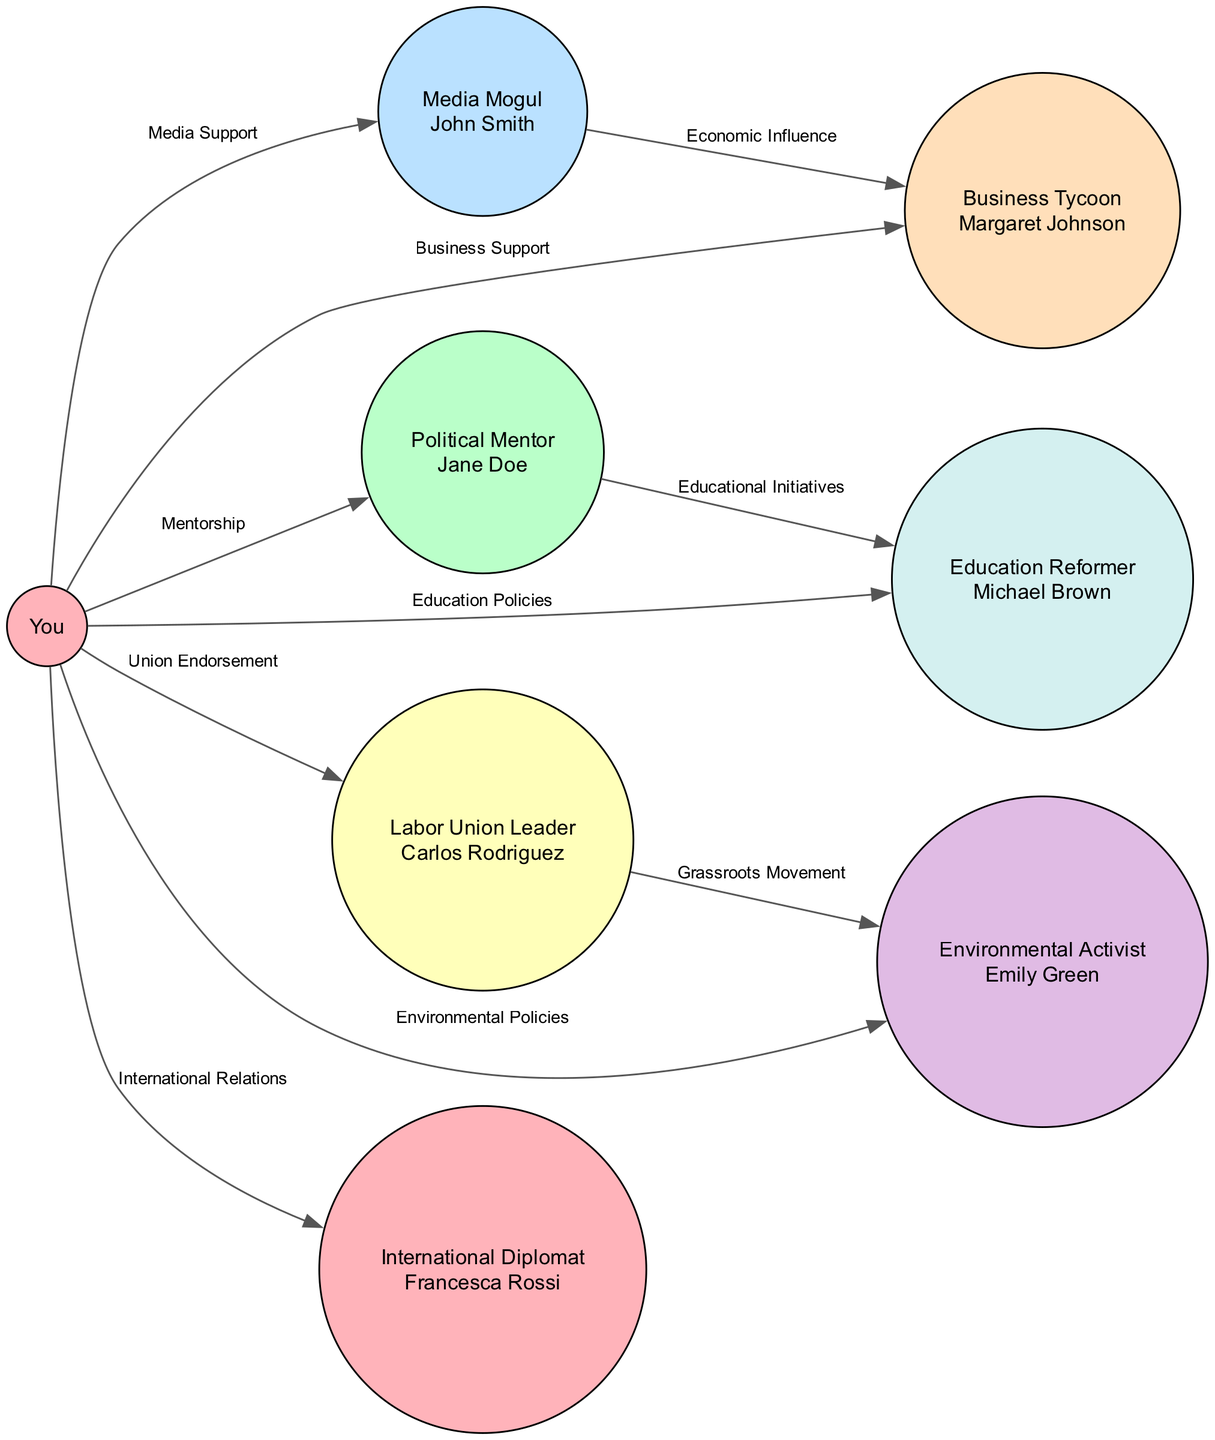What is the total number of nodes in the diagram? The nodes displayed in the diagram include you, political mentor, media mogul, labor union leader, business tycoon, environmental activist, education reformer, and international diplomat. Counting these, we find there are 8 nodes in total.
Answer: 8 What type of relationship exists between you and your political mentor? The edge connecting you to your political mentor is labeled "Mentorship." This describes the supportive relationship of guidance and advice in your political journey.
Answer: Mentorship Who is the media mogul in the diagram? The node with the label "Media Mogul" includes the title "John Smith," identifying him as the individual occupying that role in the political network.
Answer: John Smith How many edges are connected to you? There are 7 edges stemming from the node labeled "You" that show connections to various individuals through different support types. Counting these edges confirms there are 7 total.
Answer: 7 Which endorsement connects the labor union leader to the environmental activist? The edge between "Labor Union Leader" and "Environmental Activist" is labeled "Grassroots Movement," indicating the type of endorsement linking these two nodes under mutual interests or initiatives.
Answer: Grassroots Movement Which individual is linked to you through education policies? The edge corresponding to education policies connects you to the "Education Reformer," which reveals that this individual supports your initiatives in education.
Answer: Education Reformer What label is present on the edge between the media mogul and the business tycoon? The edge linking the media mogul to the business tycoon is labeled "Economic Influence," suggesting a connection based on economic matters and mutual benefit in your political landscape.
Answer: Economic Influence What is the nature of your relationship with the international diplomat? The edge linking you to the "International Diplomat" is labeled "International Relations," indicating that your connection involves diplomatic or international matters.
Answer: International Relations How many connections does the labor union leader have in total? The labor union leader has a connection to you and another edge to the environmental activist, bringing the total number of connections to 2.
Answer: 2 